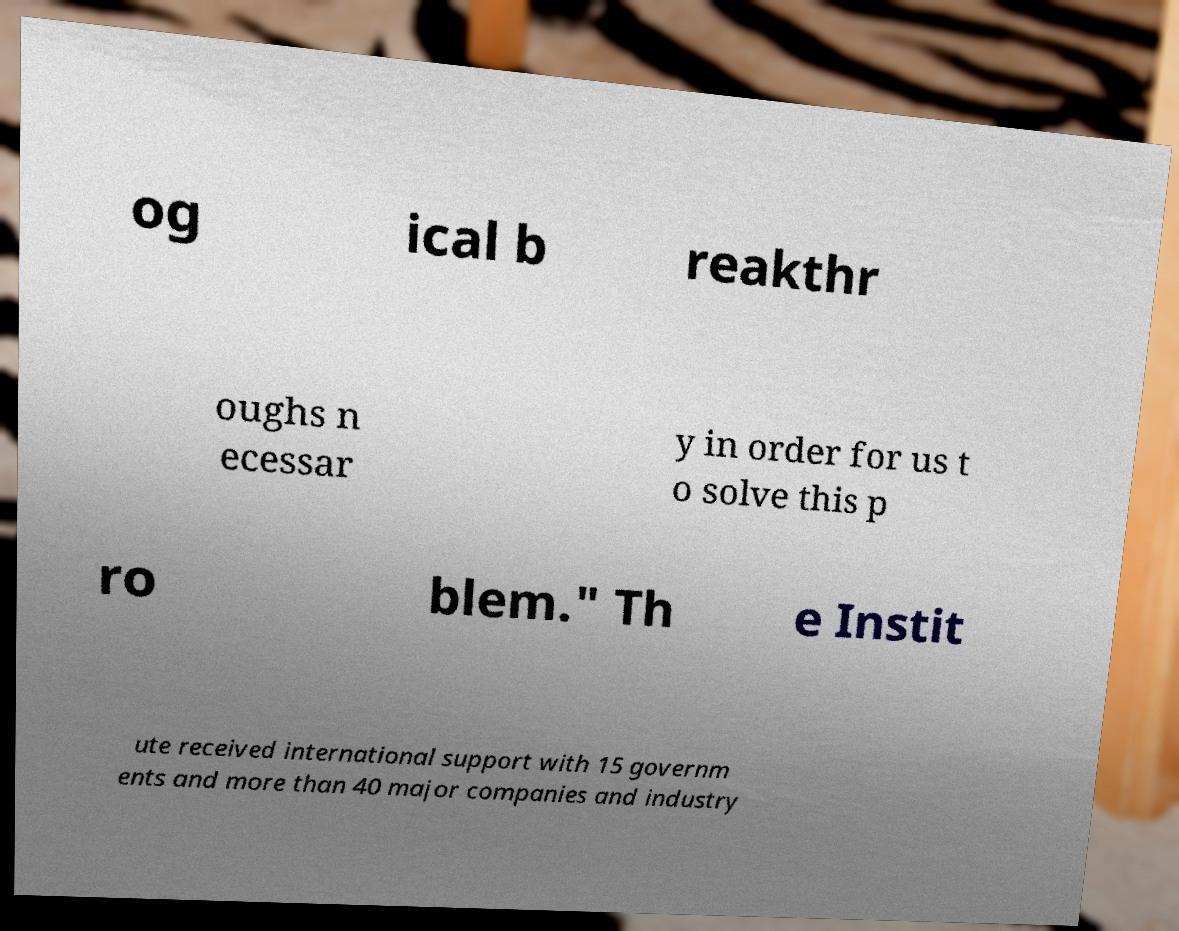Can you read and provide the text displayed in the image?This photo seems to have some interesting text. Can you extract and type it out for me? og ical b reakthr oughs n ecessar y in order for us t o solve this p ro blem." Th e Instit ute received international support with 15 governm ents and more than 40 major companies and industry 